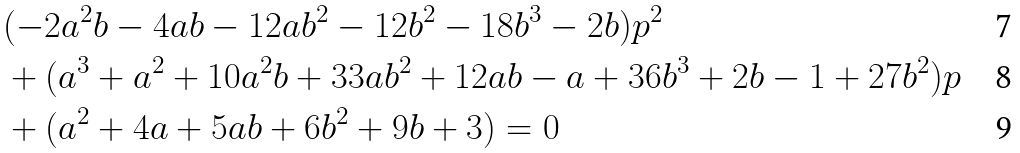Convert formula to latex. <formula><loc_0><loc_0><loc_500><loc_500>& ( - 2 a ^ { 2 } b - 4 a b - 1 2 a b ^ { 2 } - 1 2 b ^ { 2 } - 1 8 b ^ { 3 } - 2 b ) p ^ { 2 } \\ & + ( a ^ { 3 } + a ^ { 2 } + 1 0 a ^ { 2 } b + 3 3 a b ^ { 2 } + 1 2 a b - a + 3 6 b ^ { 3 } + 2 b - 1 + 2 7 b ^ { 2 } ) p \\ & + ( a ^ { 2 } + 4 a + 5 a b + 6 b ^ { 2 } + 9 b + 3 ) = 0</formula> 